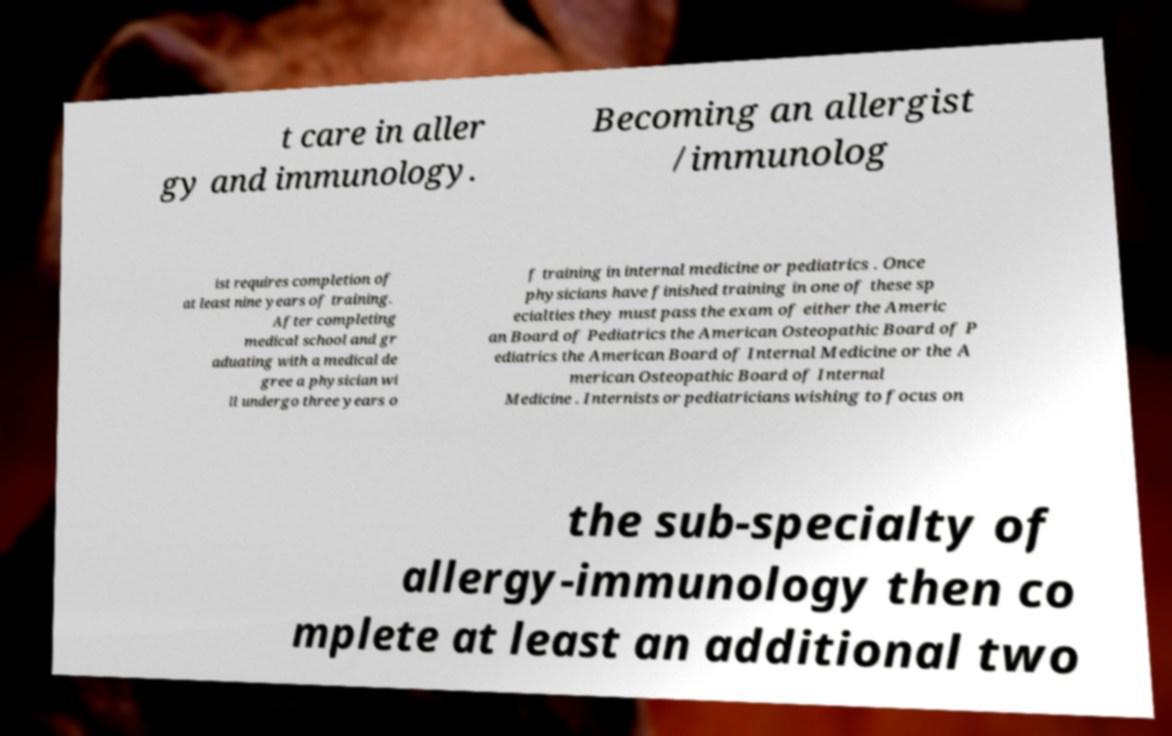Please read and relay the text visible in this image. What does it say? t care in aller gy and immunology. Becoming an allergist /immunolog ist requires completion of at least nine years of training. After completing medical school and gr aduating with a medical de gree a physician wi ll undergo three years o f training in internal medicine or pediatrics . Once physicians have finished training in one of these sp ecialties they must pass the exam of either the Americ an Board of Pediatrics the American Osteopathic Board of P ediatrics the American Board of Internal Medicine or the A merican Osteopathic Board of Internal Medicine . Internists or pediatricians wishing to focus on the sub-specialty of allergy-immunology then co mplete at least an additional two 